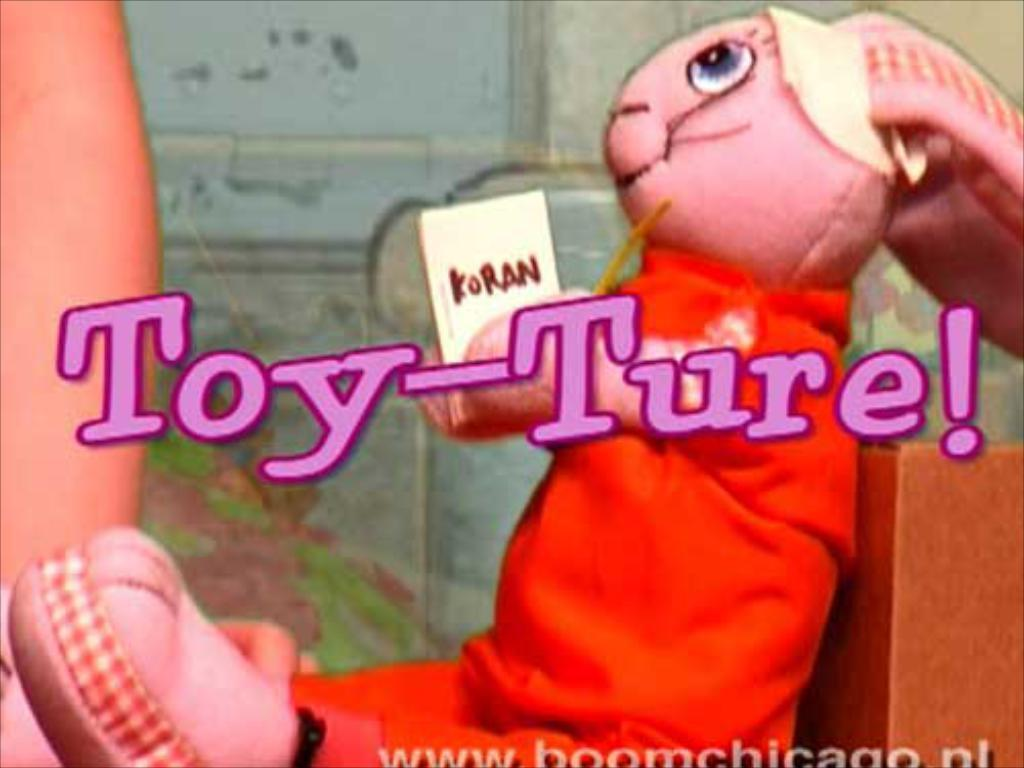What object can be seen in the image? A: There is a toy in the image. What color is the toy's dress? The toy has a red dress. What is visible in the background of the image? There is a wall in the background of the image. What can be found in the middle of the image? There is text in the middle of the image. Can you see any animals on a farm in the image? There is no farm or animals present in the image. How does the toy slip on the way in the image? The toy does not slip or move in the image; it is stationary. 